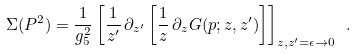<formula> <loc_0><loc_0><loc_500><loc_500>\Sigma ( P ^ { 2 } ) = \frac { 1 } { g ^ { 2 } _ { 5 } } \left [ \frac { 1 } { z ^ { \prime } } \, \partial _ { z ^ { \prime } } \left [ \frac { 1 } { z } \, \partial _ { z } G ( p ; z , z ^ { \prime } ) \right ] \right ] _ { z , z ^ { \prime } = \epsilon \rightarrow 0 } \ .</formula> 